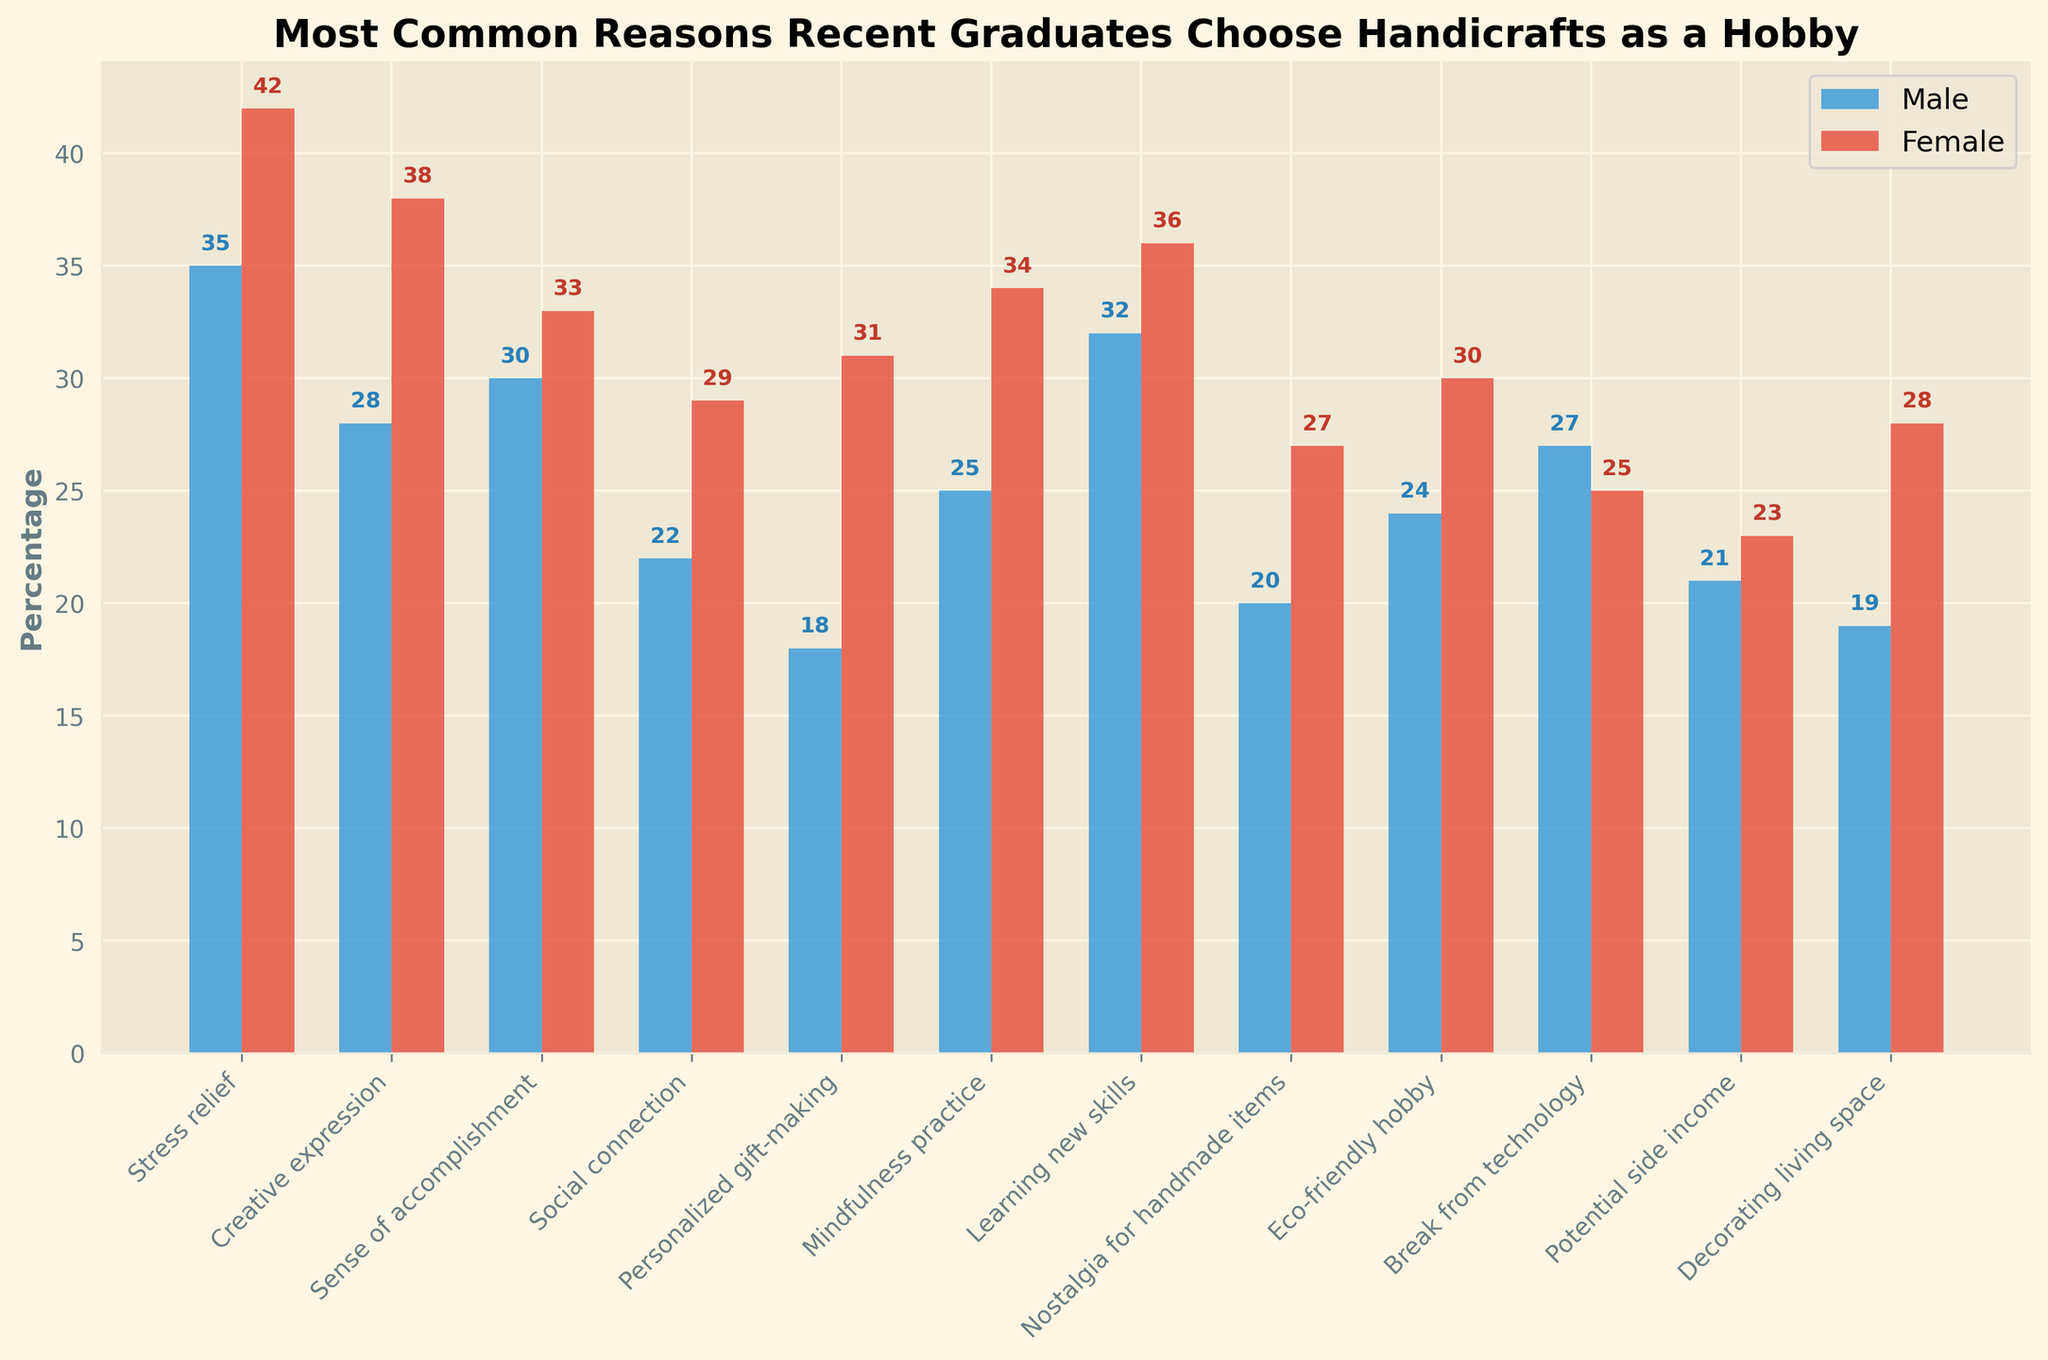Which is the most common reason for recent graduates of both genders to choose handicrafts? The highest values in both the male and female categories are for "Stress relief" with 35% for males and 42% for females, making it the most common reason across both genders.
Answer: Stress relief Which reason has the largest gender disparity in favor of females? By computing the difference between female and male percentages for each reason, "Personalized gift-making" shows the largest disparity with females at 31% and males at 18%, a difference of 13%.
Answer: Personalized gift-making Which gender values "Break from technology" more? Looking at the bar values for "Break from technology," males have a higher percentage (27%) compared to females (25%).
Answer: Males What is the average percentage for "Learning new skills" between the two genders? Add the percentages for males (32%) and females (36%) and then divide by 2 to find the average. (32 + 36) / 2 = 34%.
Answer: 34% How do the values for "Mindfulness practice" compare between males and females? The values for "Mindfulness practice" are 25% for males and 34% for females.
Answer: Females value it more Which reason ranks third for males? Sort the reasons for males: "Stress relief" (35%), "Learning new skills" (32%), and then "Sense of accomplishment" (30%).
Answer: Sense of accomplishment How many reasons have a higher percentage for females compared to males? Count the reasons where the female percentage is higher than the male percentage: 7 reasons ("Stress relief," "Creative expression," "Sense of accomplishment," "Social connection," "Personalized gift-making," "Mindfulness practice," "Nostalgia for handmade items," "Eco-friendly hobby," and "Decorating living space").
Answer: 9 reasons What is the combined percentage for "Social connection" for both genders? Add the percentages for males (22%) and females (29%) to get the combined percentage. 22 + 29 = 51%.
Answer: 51% Which reason has the closest values between males and females? Calculate the absolute differences for each reason and find the smallest: "Break from technology" has 27% for males and 25% for females; the difference is 2%, the smallest among the reasons.
Answer: Break from technology What is the total percentage of males who choose either "Decorating living space" or "Eco-friendly hobby"? Add the percentages for males for "Decorating living space" (19%) and "Eco-friendly hobby" (24%). 19 + 24 = 43%.
Answer: 43% 